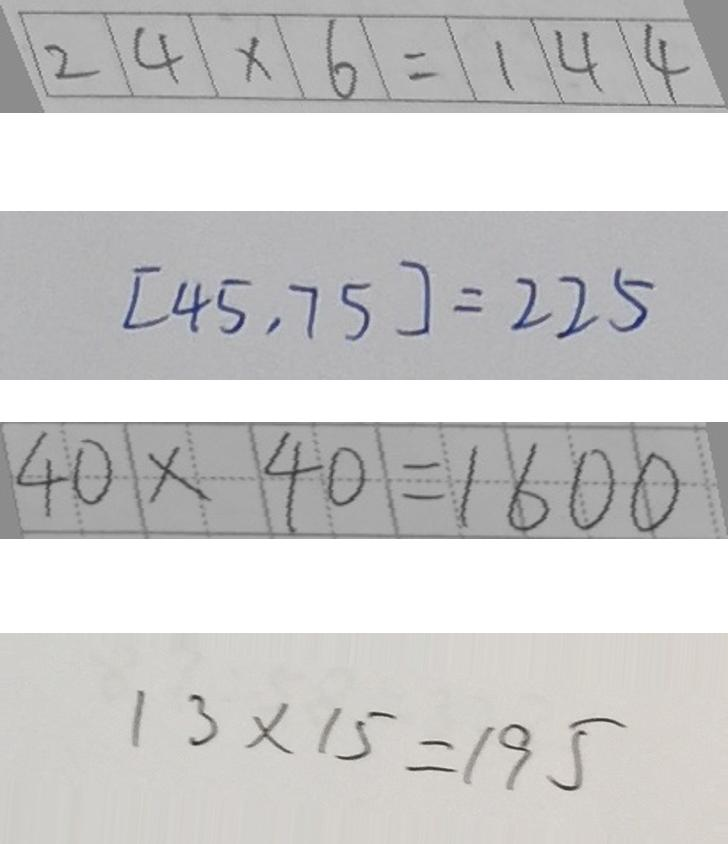<formula> <loc_0><loc_0><loc_500><loc_500>2 4 \times 6 = 1 4 4 
 [ 4 5 , 7 5 ] = 2 2 5 
 4 0 \times 4 0 = 1 6 0 0 
 1 3 \times 1 5 = 1 9 5</formula> 